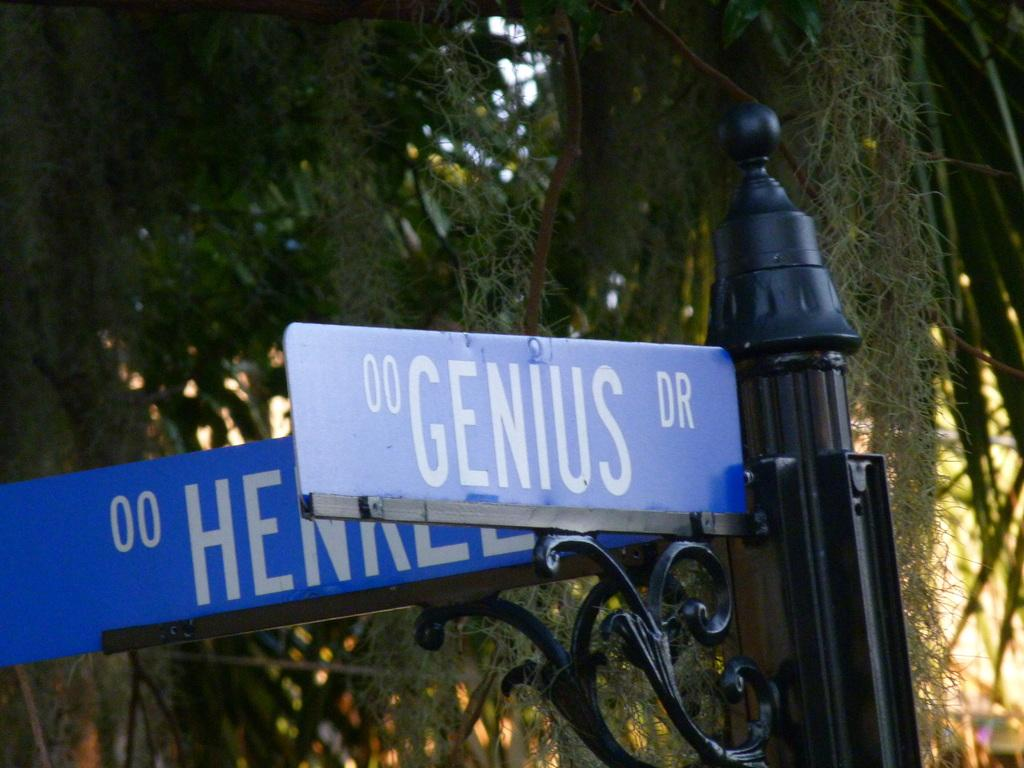How many sign boards are present in the image? There are two sign boards in the image. What is the color of the pole in the image? The pole in the image is black. What can be seen in the background of the image? There are trees in the background of the image. What type of scent can be smelled coming from the sign boards in the image? There is no indication of any scent associated with the sign boards in the image. What type of material is the boy made of in the image? There is no boy present in the image. 